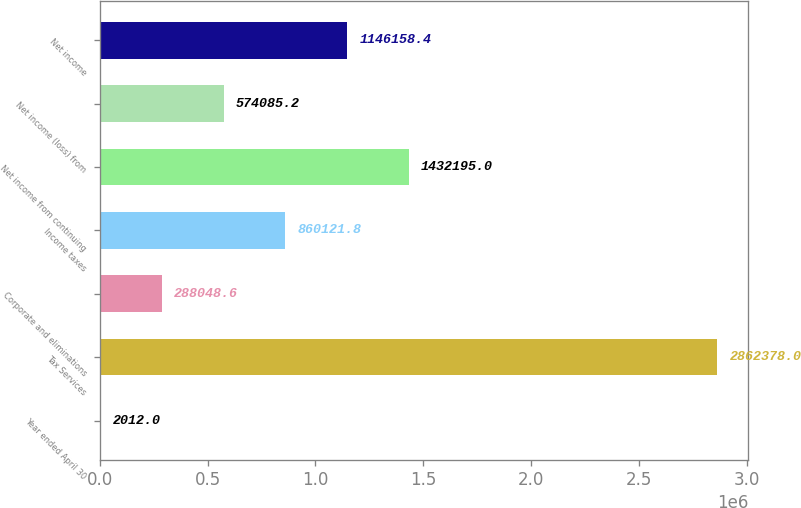Convert chart. <chart><loc_0><loc_0><loc_500><loc_500><bar_chart><fcel>Year ended April 30<fcel>Tax Services<fcel>Corporate and eliminations<fcel>Income taxes<fcel>Net income from continuing<fcel>Net income (loss) from<fcel>Net income<nl><fcel>2012<fcel>2.86238e+06<fcel>288049<fcel>860122<fcel>1.4322e+06<fcel>574085<fcel>1.14616e+06<nl></chart> 